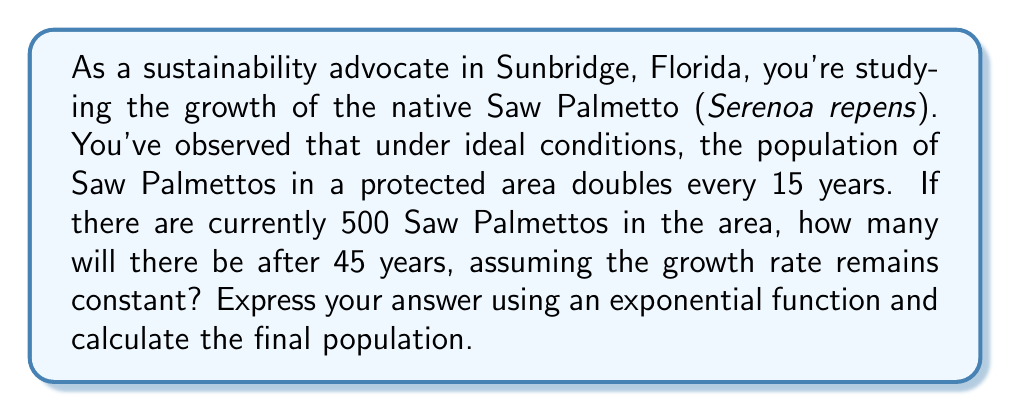Can you solve this math problem? To solve this problem, we'll use an exponential growth function. The general form of an exponential growth function is:

$$A(t) = A_0 \cdot b^t$$

Where:
$A(t)$ is the amount after time $t$
$A_0$ is the initial amount
$b$ is the growth factor
$t$ is the time

1) First, we need to determine the growth factor $b$. We know the population doubles every 15 years, so:

   $$2 = b^{15}$$
   $$b = 2^{\frac{1}{15}} \approx 1.0472$$

2) Now we can set up our exponential function:

   $$A(t) = 500 \cdot (1.0472)^{\frac{t}{15}}$$

   We use $\frac{t}{15}$ as the exponent because the growth factor is per 15-year period.

3) We want to know the population after 45 years, so we plug in $t = 45$:

   $$A(45) = 500 \cdot (1.0472)^{\frac{45}{15}} = 500 \cdot (1.0472)^3$$

4) Calculate the result:

   $$A(45) = 500 \cdot (1.0472)^3 \approx 500 \cdot 1.149 \approx 574.5$$

5) Since we're dealing with whole plants, we round to the nearest integer:

   $$A(45) \approx 575$$

Therefore, after 45 years, there will be approximately 575 Saw Palmettos in the protected area.
Answer: The exponential function describing the growth is $A(t) = 500 \cdot (1.0472)^{\frac{t}{15}}$, and the population after 45 years will be approximately 575 Saw Palmettos. 